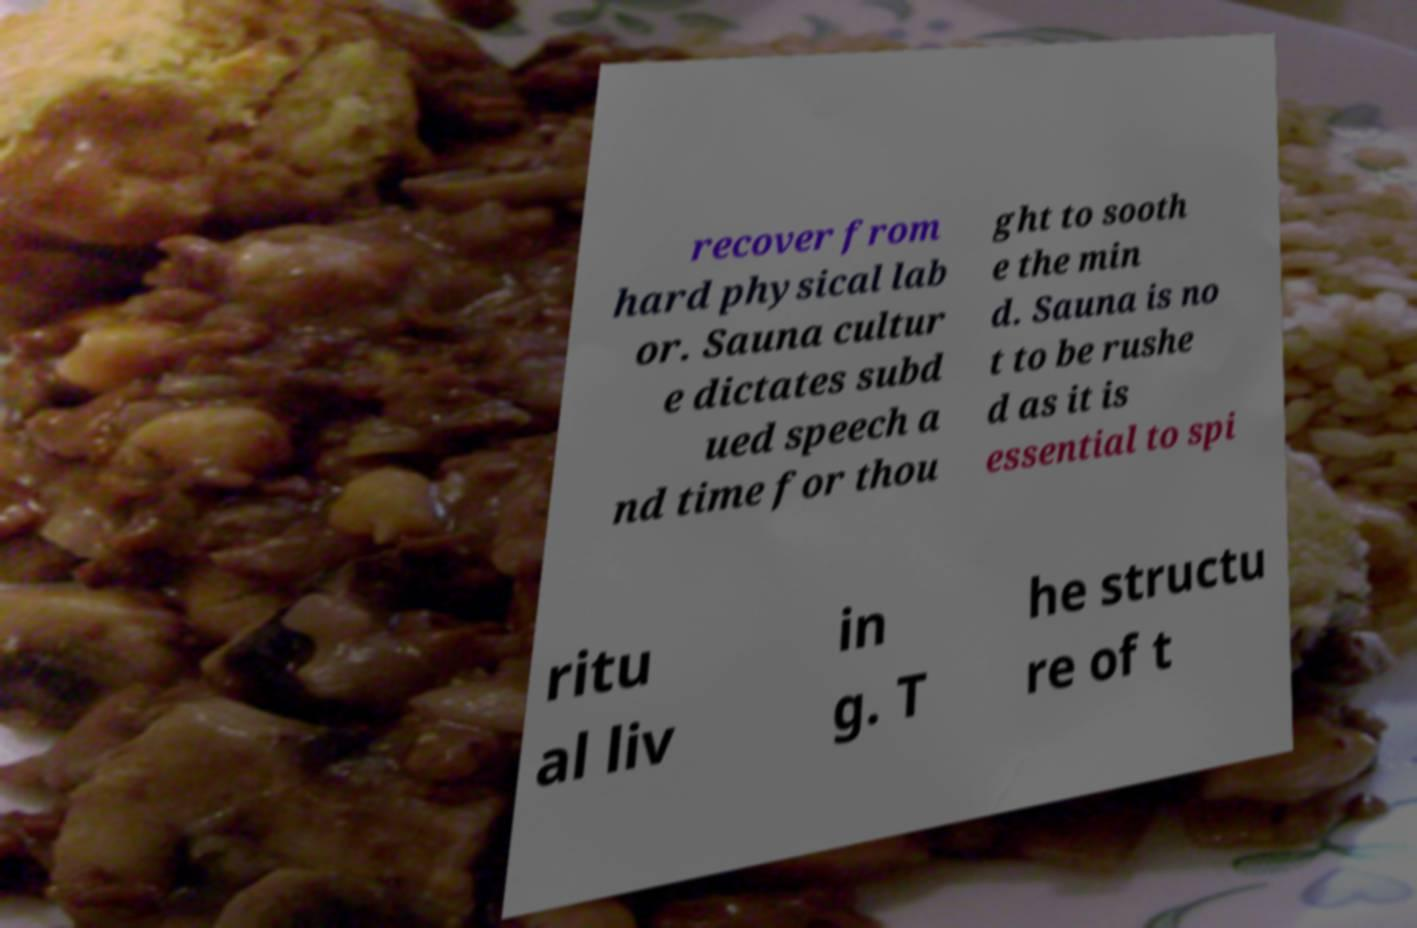Can you accurately transcribe the text from the provided image for me? recover from hard physical lab or. Sauna cultur e dictates subd ued speech a nd time for thou ght to sooth e the min d. Sauna is no t to be rushe d as it is essential to spi ritu al liv in g. T he structu re of t 